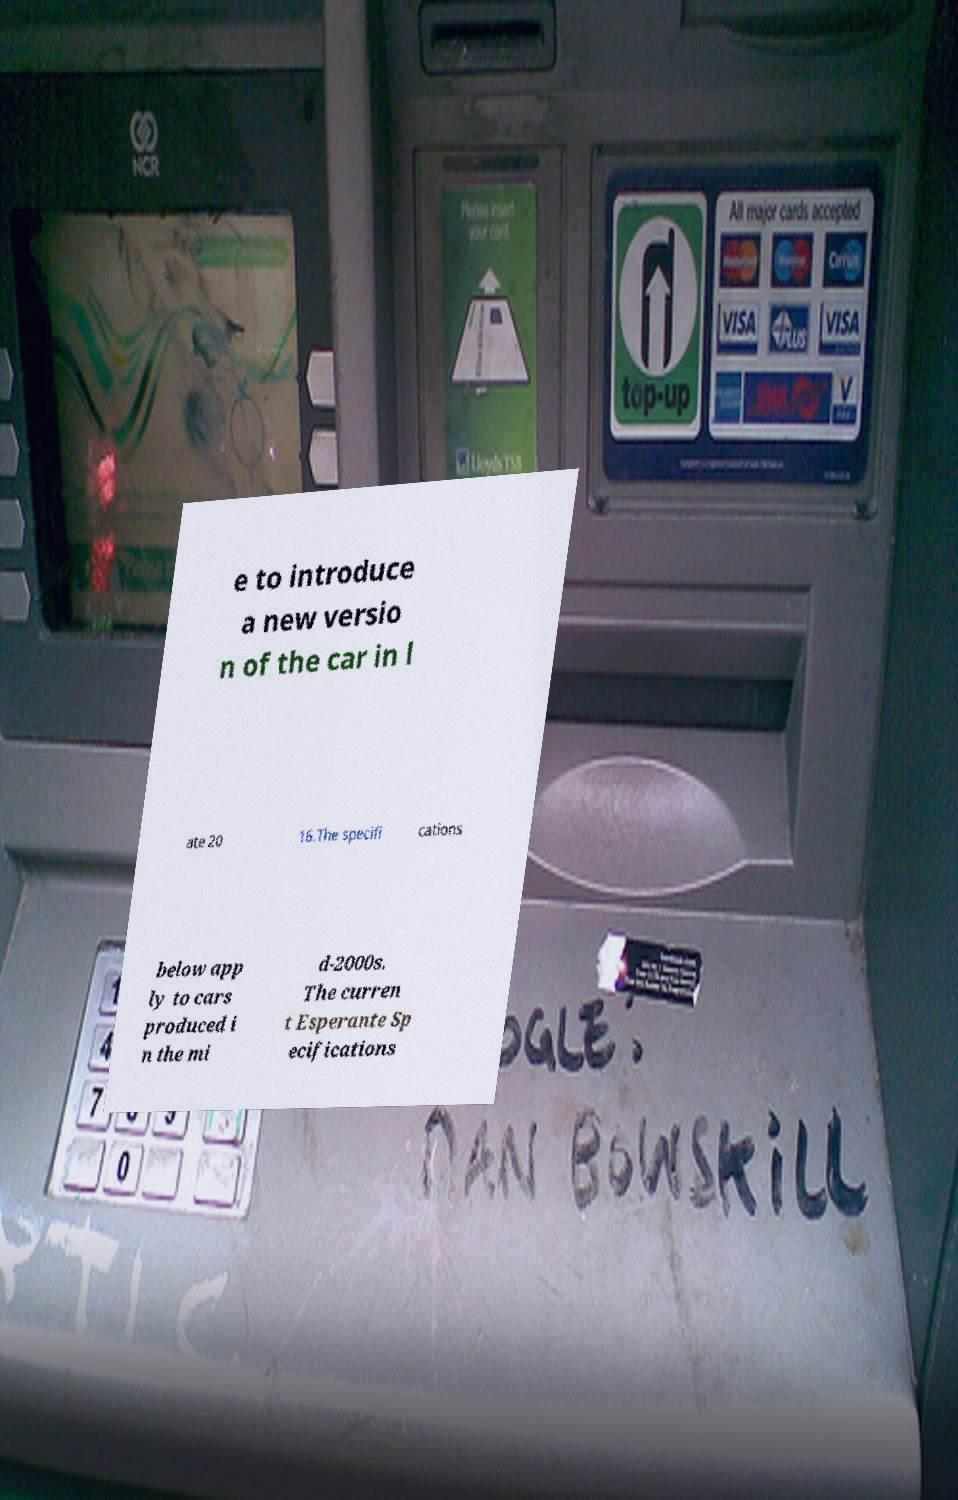For documentation purposes, I need the text within this image transcribed. Could you provide that? e to introduce a new versio n of the car in l ate 20 16.The specifi cations below app ly to cars produced i n the mi d-2000s. The curren t Esperante Sp ecifications 